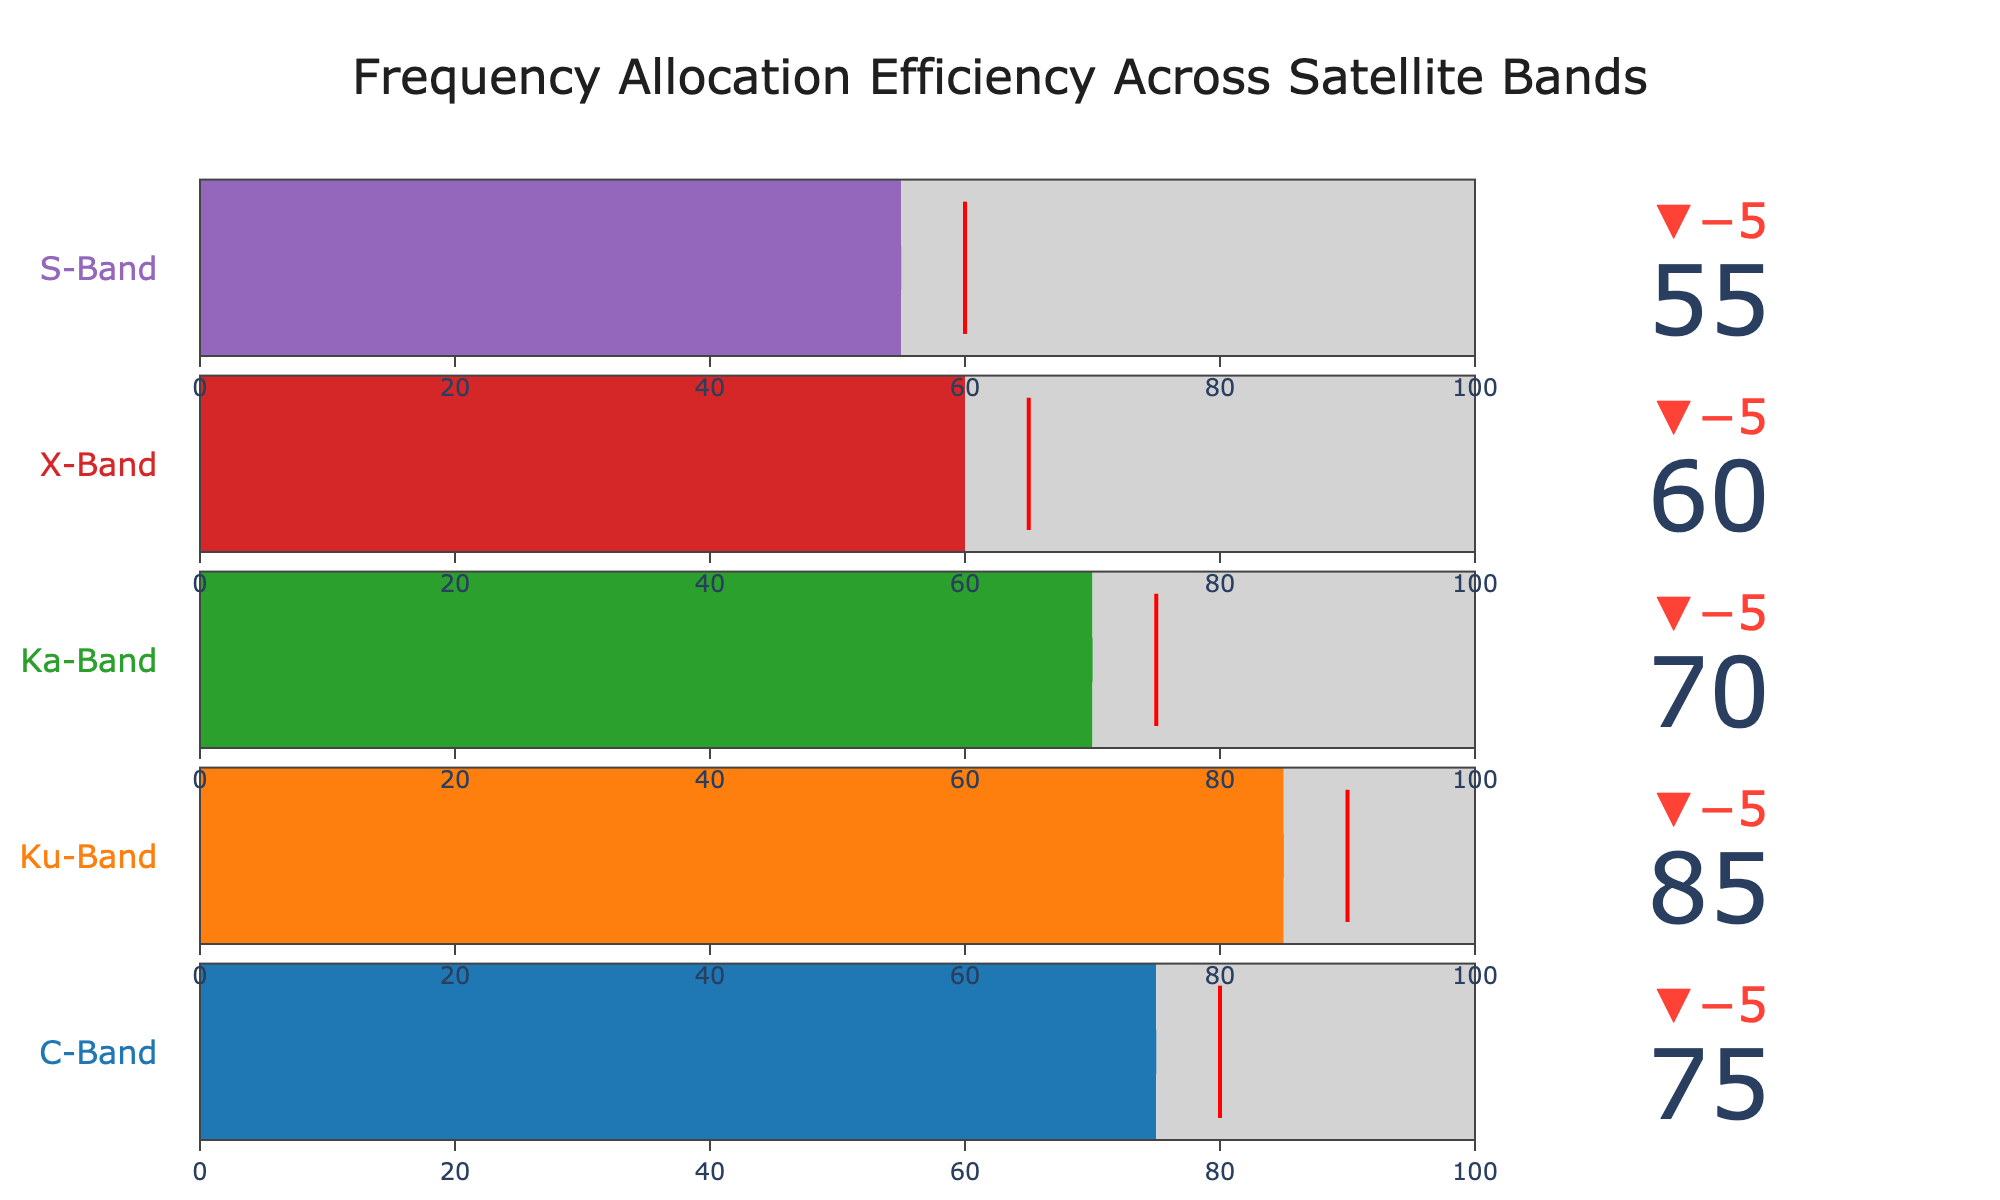What's the title of the figure? The title is located at the top center of the figure. It reads "Frequency Allocation Efficiency Across Satellite Bands".
Answer: Frequency Allocation Efficiency Across Satellite Bands How many satellite bands are depicted in the figure? Count the individual titles for each band listed vertically in the figure. There are five satellite bands: C-Band, Ku-Band, Ka-Band, X-Band, and S-Band.
Answer: 5 Which satellite band has the highest frequency allocation efficiency? By comparing the "Actual" values for each band, the Ku-Band has the highest frequency allocation efficiency with a value of 85.
Answer: Ku-Band What is the target frequency allocation for the Ka-Band? Look at the indicator line in red for the Ka-Band within the figure. The target value is represented, which is 75.
Answer: 75 What is the difference between the actual and target values for the X-Band? Subtract the target value for X-Band (65) from its actual value (60). 60 - 65 = -5.
Answer: -5 How does the efficiency of the S-Band compare to its target? The actual efficiency of the S-Band is 55, and the target is 60. Since 55 is less than 60, the S-Band does not meet its target.
Answer: Less What is the combined target frequency allocation for C-Band and Ku-Band? Sum the target values for C-Band (80) and Ku-Band (90). 80 + 90 = 170.
Answer: 170 Which satellite band is closest to reaching its target allocation? Calculate the difference between the actual and target values for each band, and find the smallest difference. Ku-Band has 85 - 90 = -5, so the Ka-Band is closest with 70 - 75 = -5.
Answer: Ka-Band What is the visual indication of the threshold in the figure? The threshold is indicated by a red line within each gauge, showing the target frequency allocation value for each band.
Answer: Red line Which satellite band has the lowest maximum possible frequency allocation? All bands have the same maximum possible frequency allocation, which is 100.
Answer: All bands 